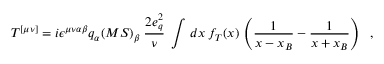Convert formula to latex. <formula><loc_0><loc_0><loc_500><loc_500>T ^ { [ \mu \nu ] } = i \epsilon ^ { \mu \nu \alpha \beta } q _ { \alpha } ( M S ) _ { \beta } \, { \frac { 2 e _ { q } ^ { 2 } } { \nu } } \, \int \, d x \, f _ { T } ( x ) \, \left ( { \frac { 1 } { x - x _ { B } } } - { \frac { 1 } { x + x _ { B } } } \right ) \, ,</formula> 